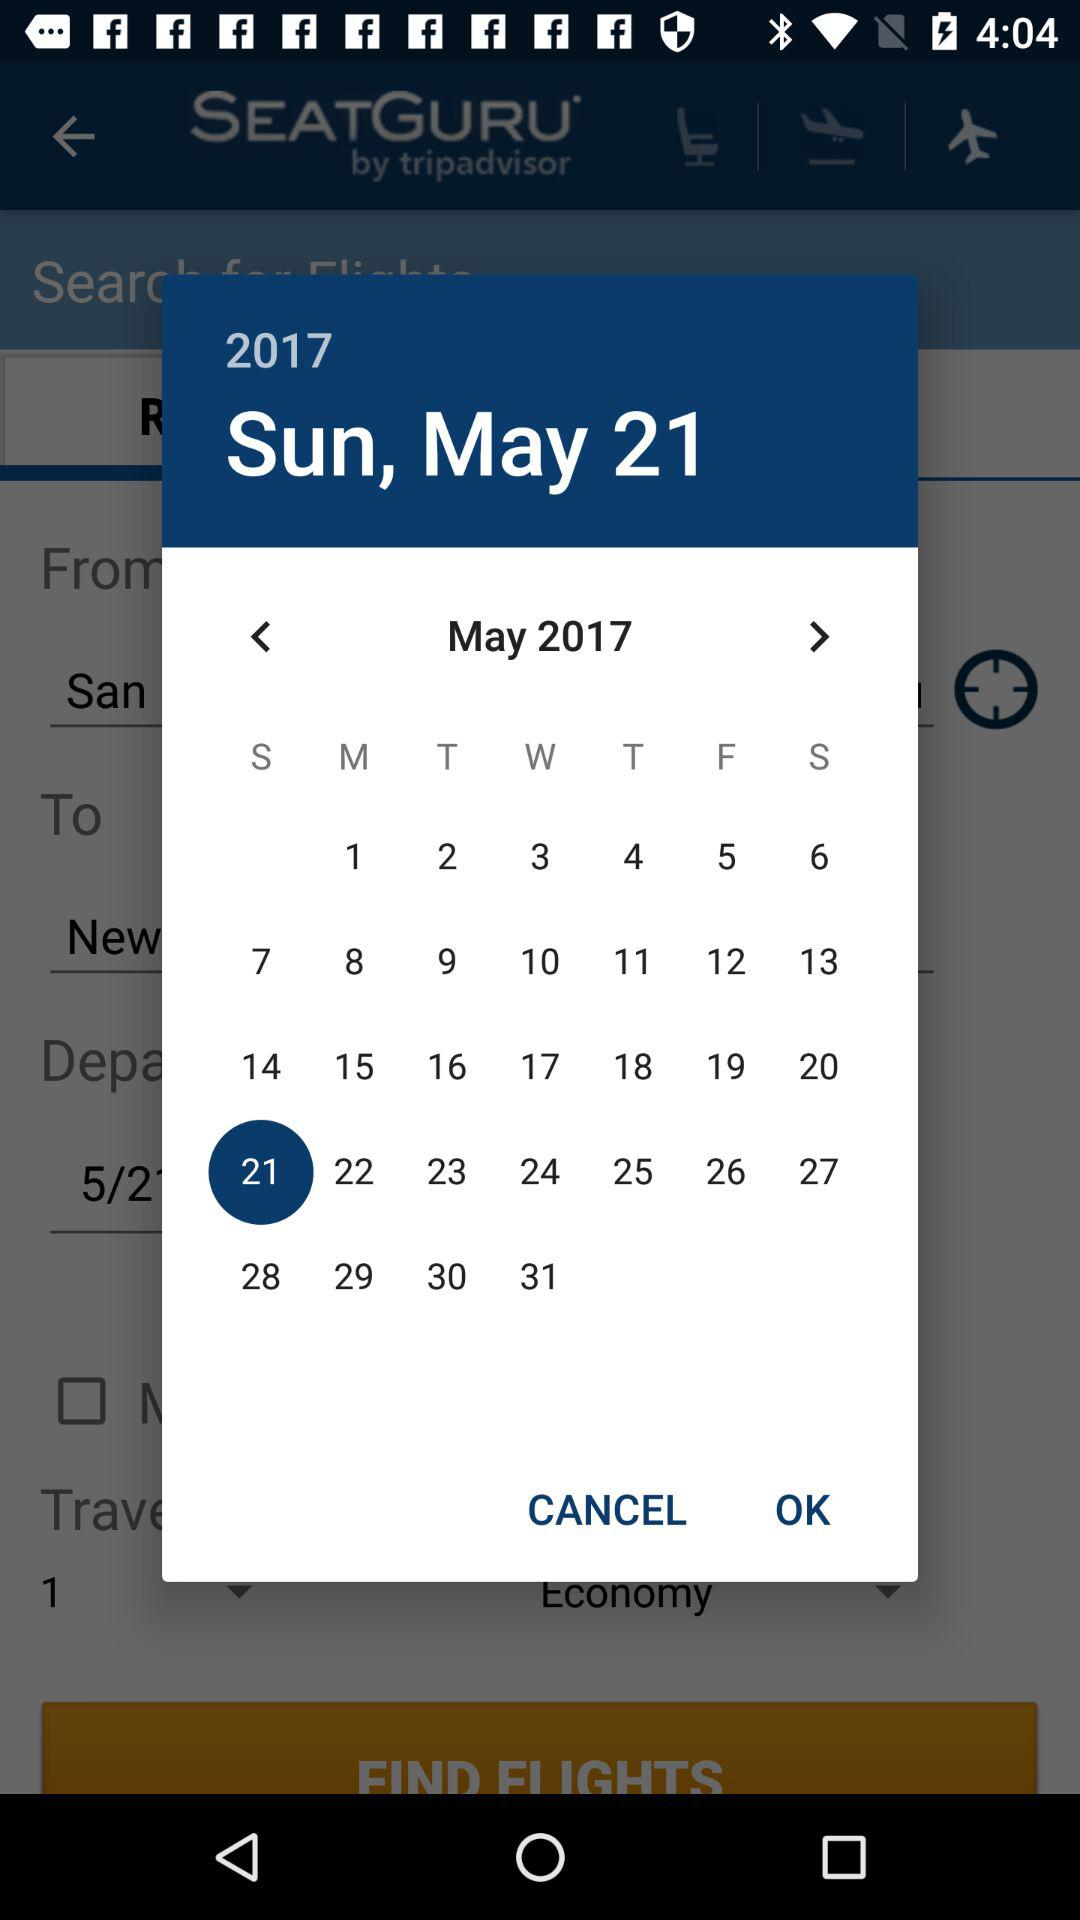Which year is mentioned? The mentioned year is 2017. 